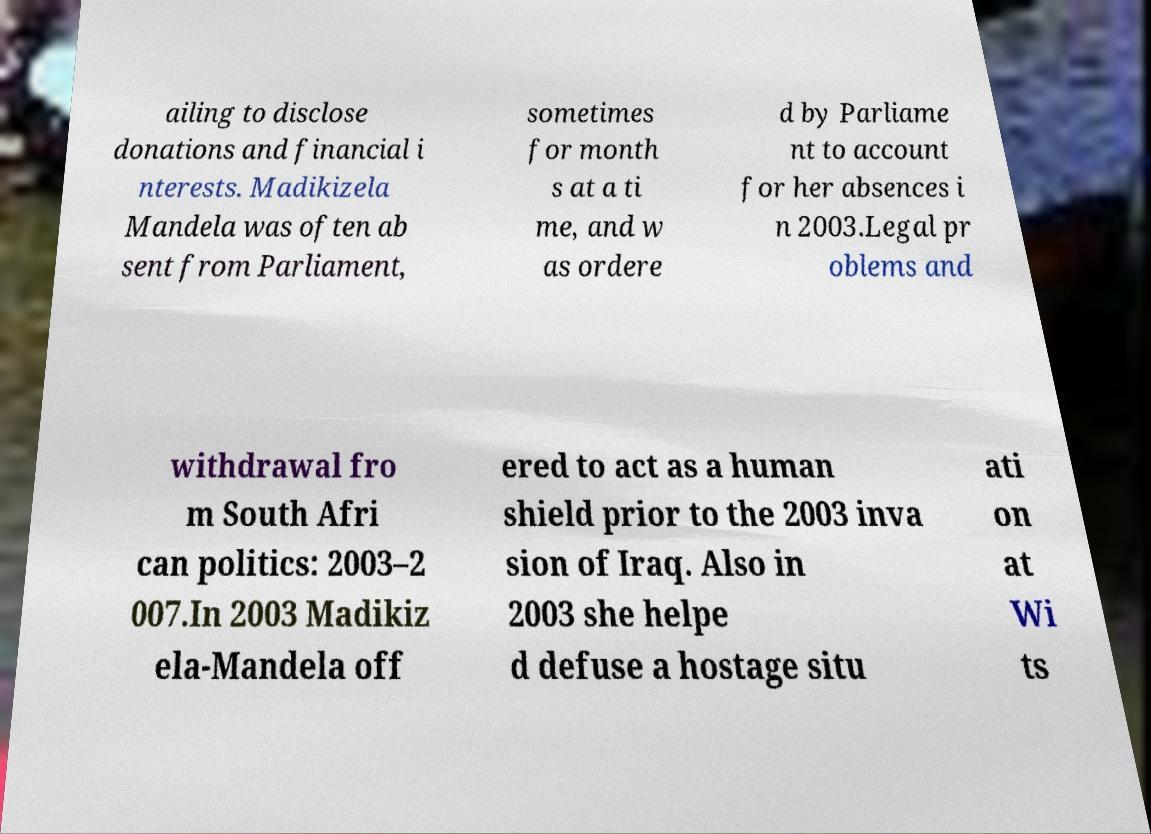What messages or text are displayed in this image? I need them in a readable, typed format. ailing to disclose donations and financial i nterests. Madikizela Mandela was often ab sent from Parliament, sometimes for month s at a ti me, and w as ordere d by Parliame nt to account for her absences i n 2003.Legal pr oblems and withdrawal fro m South Afri can politics: 2003–2 007.In 2003 Madikiz ela-Mandela off ered to act as a human shield prior to the 2003 inva sion of Iraq. Also in 2003 she helpe d defuse a hostage situ ati on at Wi ts 